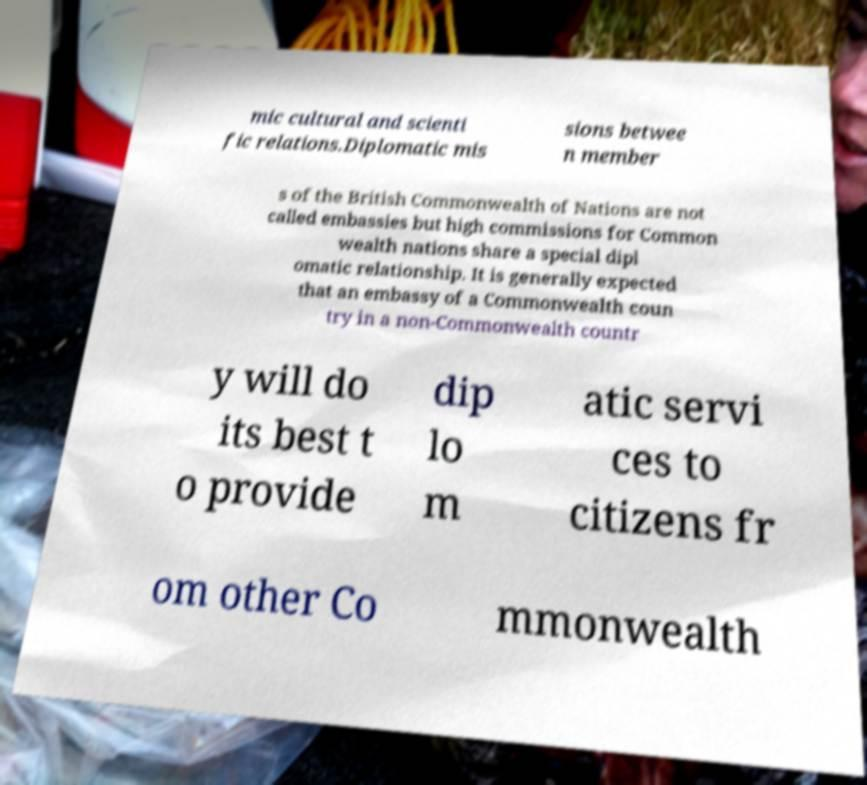Could you extract and type out the text from this image? mic cultural and scienti fic relations.Diplomatic mis sions betwee n member s of the British Commonwealth of Nations are not called embassies but high commissions for Common wealth nations share a special dipl omatic relationship. It is generally expected that an embassy of a Commonwealth coun try in a non-Commonwealth countr y will do its best t o provide dip lo m atic servi ces to citizens fr om other Co mmonwealth 